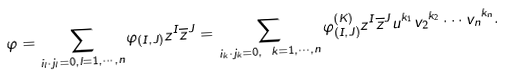Convert formula to latex. <formula><loc_0><loc_0><loc_500><loc_500>\varphi = \sum _ { i _ { l } \cdot j _ { l } = 0 , l = 1 , \cdots , n } \varphi _ { ( I , J ) } z ^ { I } { \overline { z } } ^ { J } = \sum _ { i _ { k } \cdot j _ { k } = 0 , \ k = 1 , \cdots , n } \varphi _ { ( I , J ) } ^ { ( K ) } z ^ { I } { \overline { z } } ^ { J } u ^ { k _ { 1 } } { v _ { 2 } } ^ { k _ { 2 } } \cdots { v _ { n } } ^ { k _ { n } } .</formula> 